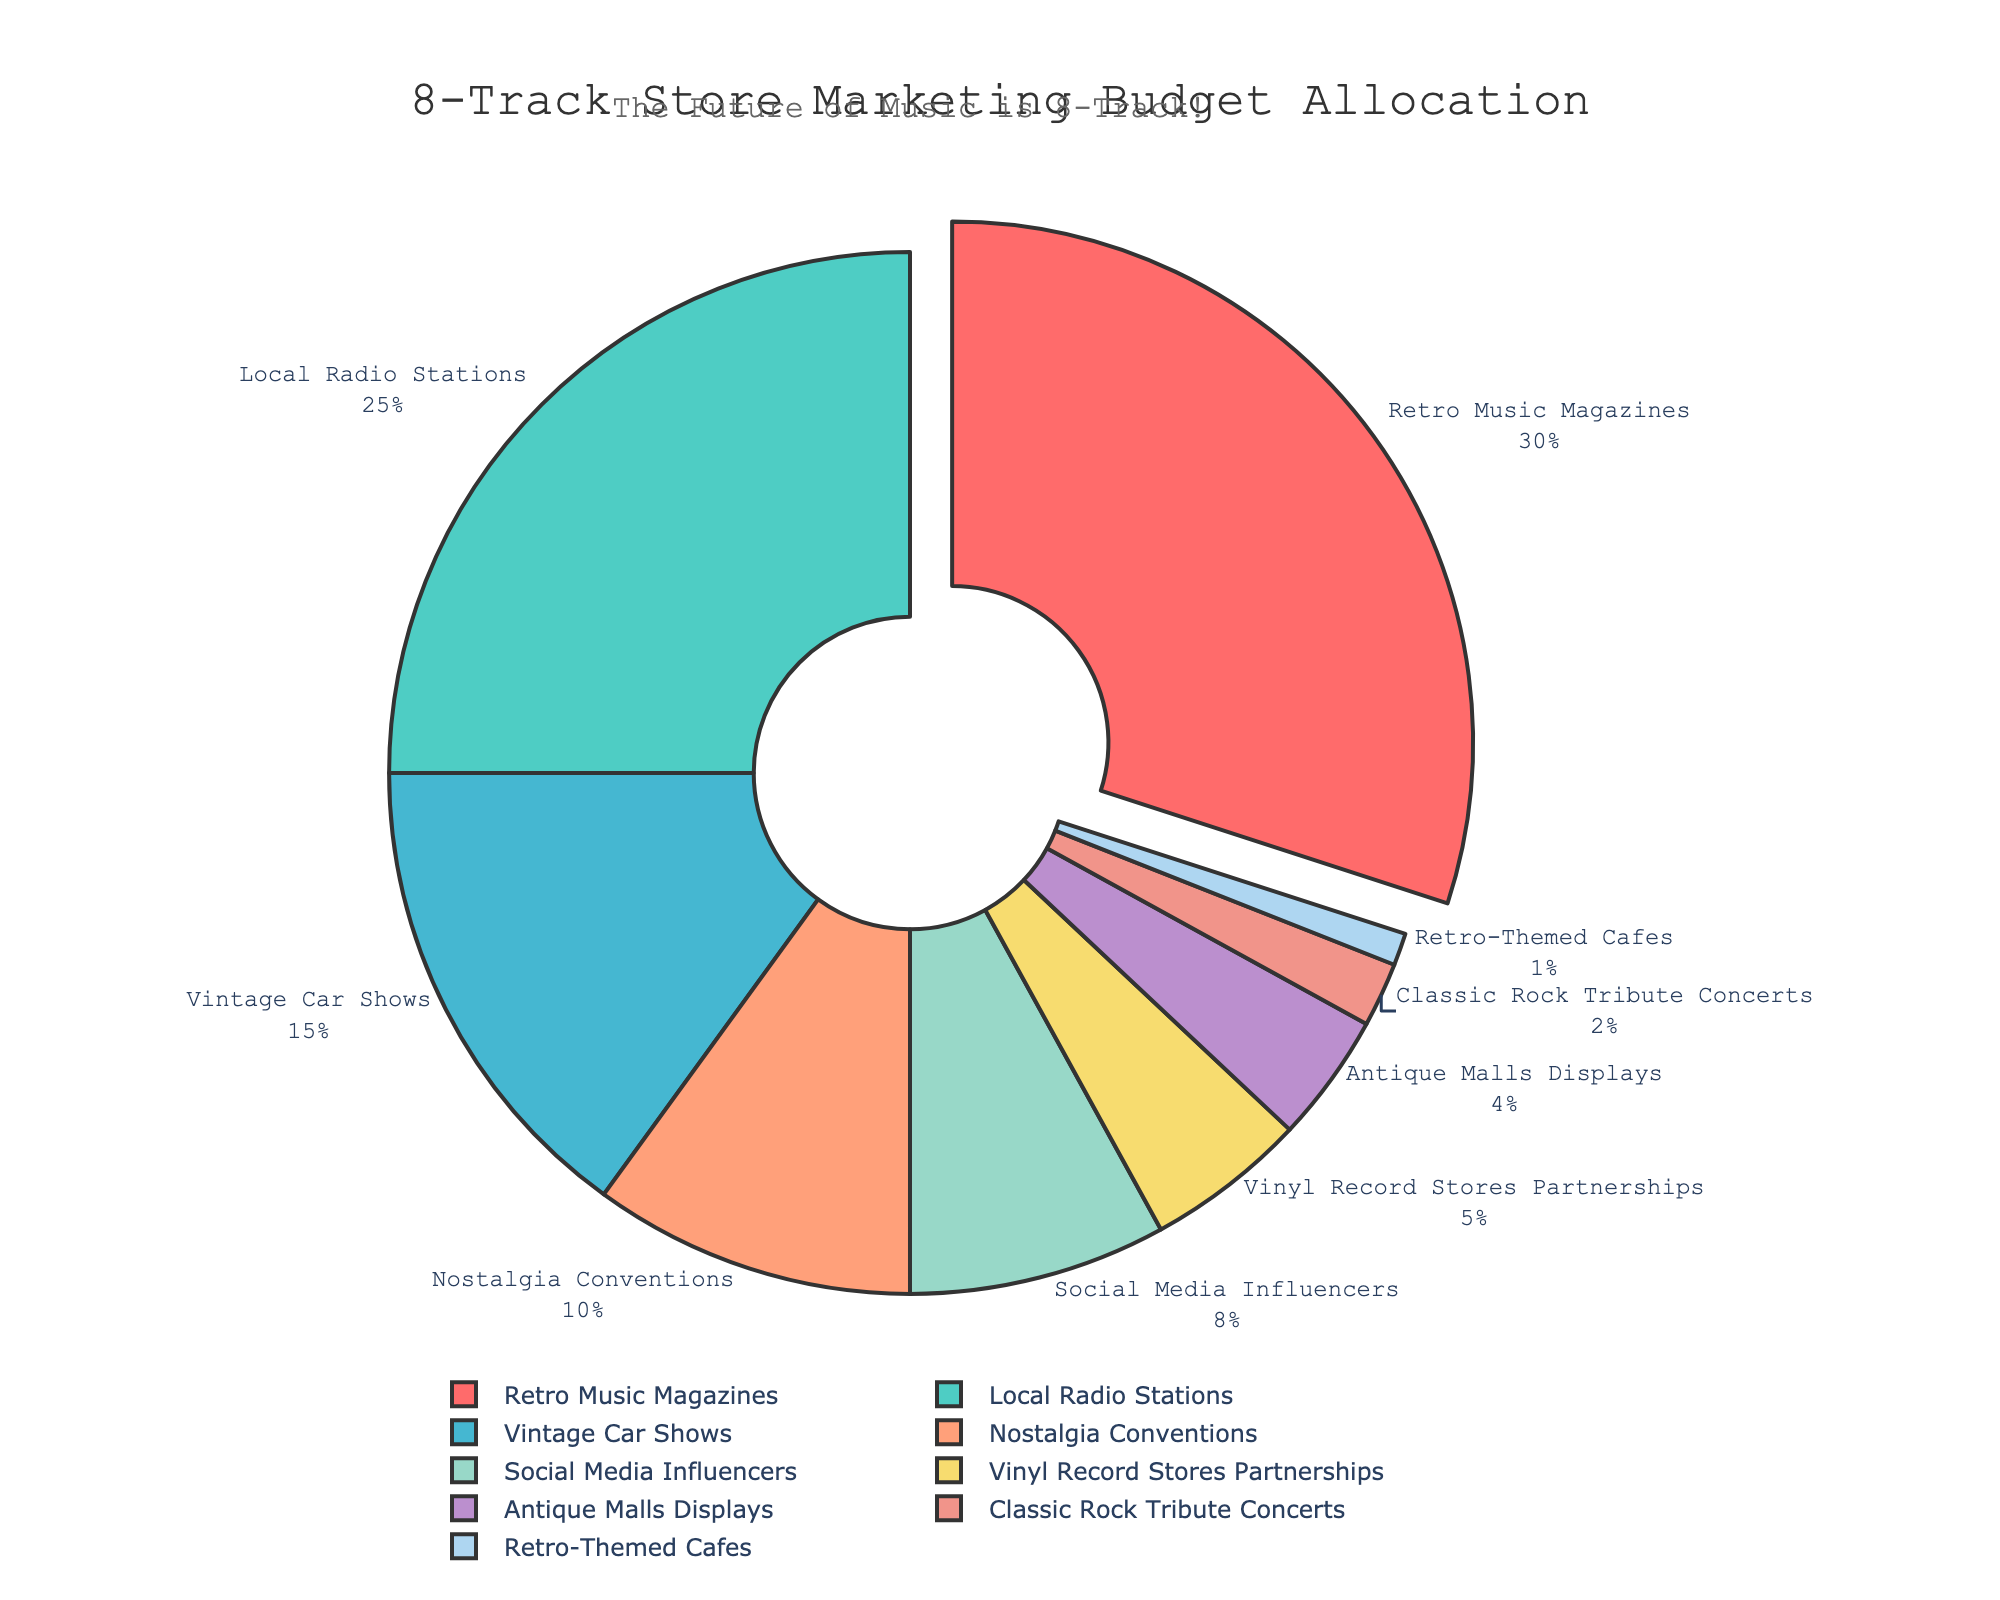What is the largest allocation in the marketing budget? The largest portion of the pie chart is labeled as "Retro Music Magazines," which also has the text indicating 30%. Hence, "Retro Music Magazines" has the largest allocation.
Answer: Retro Music Magazines Which promotional channel has the smallest allocation? The smallest segment of the pie chart is labeled as "Retro-Themed Cafes" with a corresponding percentage of 1%. Therefore, "Retro-Themed Cafes" has the smallest allocation.
Answer: Retro-Themed Cafes How much of the budget is allocated to Local Radio Stations and Vintage Car Shows combined? The pie chart shows "Local Radio Stations" with 25% and "Vintage Car Shows" with 15%. Adding these percentages gives 25% + 15% = 40%.
Answer: 40% What is the total percentage allocated to partnerships and displays combined (Vinyl Record Stores Partnerships and Antique Malls Displays)? The segments for "Vinyl Record Stores Partnerships" and "Antique Malls Displays" show 5% and 4% respectively. Summing them yields 5% + 4% = 9%.
Answer: 9% Do Nostalgia Conventions receive more budget allocation than Social Media Influencers? The pie chart lists "Nostalgia Conventions" with 10% and "Social Media Influencers" with 8%. Therefore, Nostalgia Conventions have a higher allocation.
Answer: Yes How does the budget allocation for Classic Rock Tribute Concerts compare to Retro-Themed Cafes? "Classic Rock Tribute Concerts" have a 2% allocation while "Retro-Themed Cafes" have a 1% allocation. Thus, Classic Rock Tribute Concerts have a higher budget allocation.
Answer: Classic Rock Tribute Concerts have more Which channels are allocated more than 10% of the budget? The segments with more than 10% allocation in the pie chart are "Retro Music Magazines" (30%) and "Local Radio Stations" (25%).
Answer: Retro Music Magazines, Local Radio Stations What is the average budget allocation of all channels? To find the average, sum all percentages and divide by the number of channels: (30 + 25 + 15 + 10 + 8 + 5 + 4 + 2 + 1) / 9 = 12.22%.
Answer: 12.22% How much more budget is allocated to Local Radio Stations than to Classic Rock Tribute Concerts? "Local Radio Stations" have 25% allocated, and "Classic Rock Tribute Concerts" have 2%. The difference is 25% - 2% = 23%.
Answer: 23% 